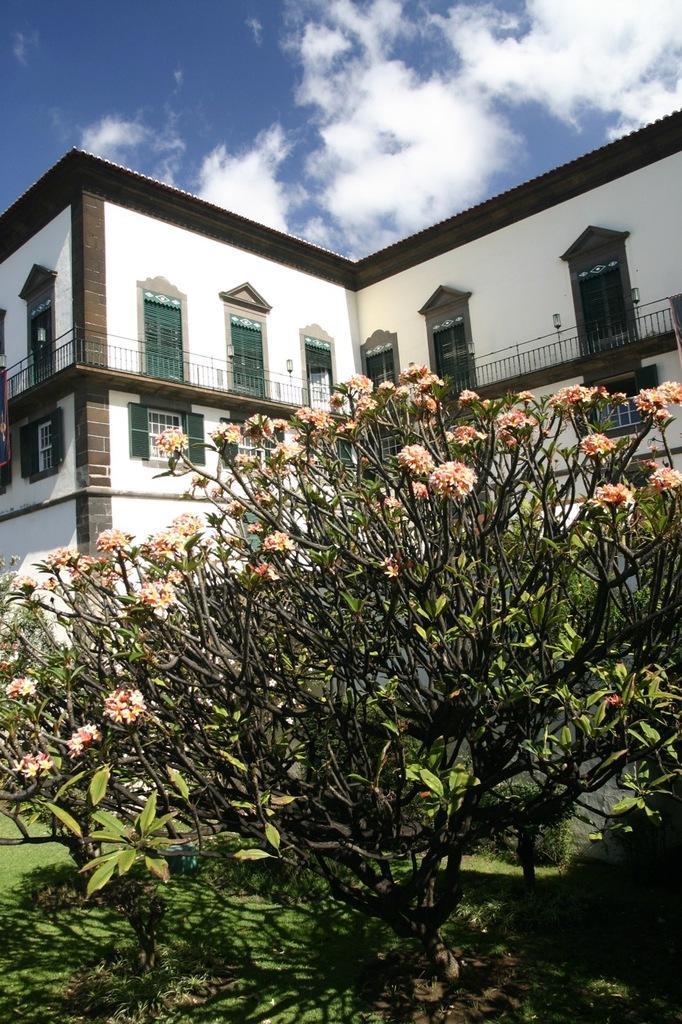Can you describe this image briefly? In this image there are flowers on a plant, behind the plant there is a building. 